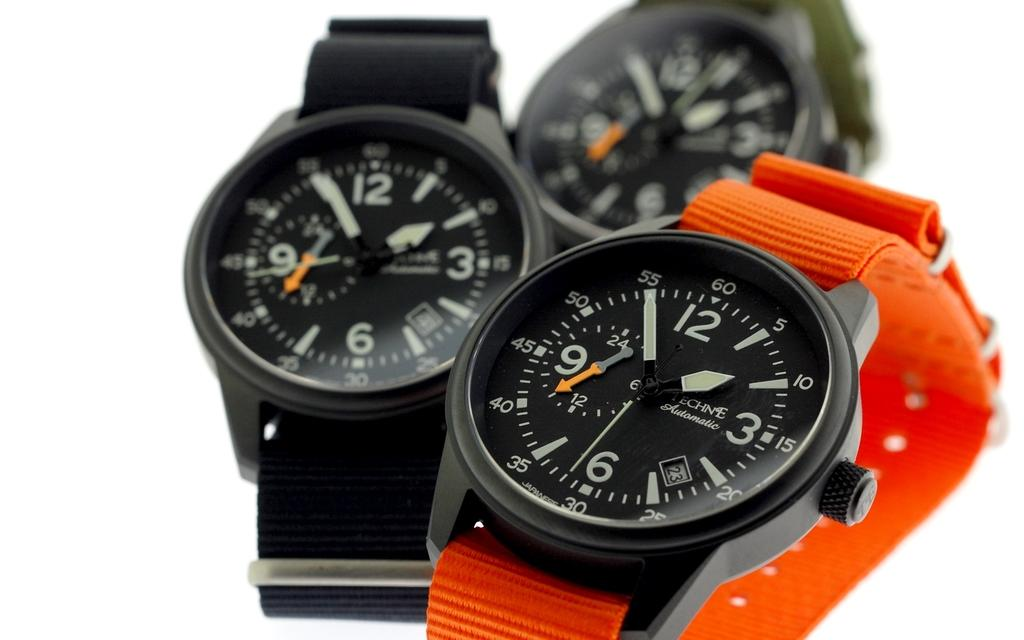<image>
Describe the image concisely. Three watches are against a white backdrop, and they say it is about 1:55. 